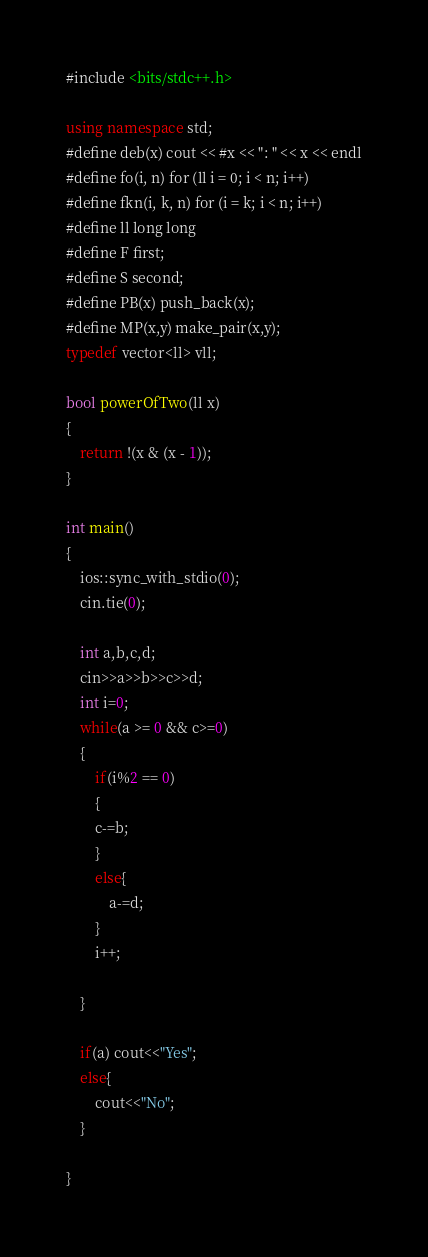<code> <loc_0><loc_0><loc_500><loc_500><_C++_>#include <bits/stdc++.h>

using namespace std;
#define deb(x) cout << #x << ": " << x << endl
#define fo(i, n) for (ll i = 0; i < n; i++)
#define fkn(i, k, n) for (i = k; i < n; i++)
#define ll long long
#define F first;
#define S second;
#define PB(x) push_back(x);
#define MP(x,y) make_pair(x,y);
typedef vector<ll> vll;

bool powerOfTwo(ll x)
{
    return !(x & (x - 1));
}

int main()
{
    ios::sync_with_stdio(0);
    cin.tie(0);
    
    int a,b,c,d;
    cin>>a>>b>>c>>d;
    int i=0;
    while(a >= 0 && c>=0)
    {
        if(i%2 == 0)
        {
        c-=b;
        }
        else{
            a-=d;
        }
        i++;

    }

    if(a) cout<<"Yes";
    else{
        cout<<"No";
    }

}

</code> 